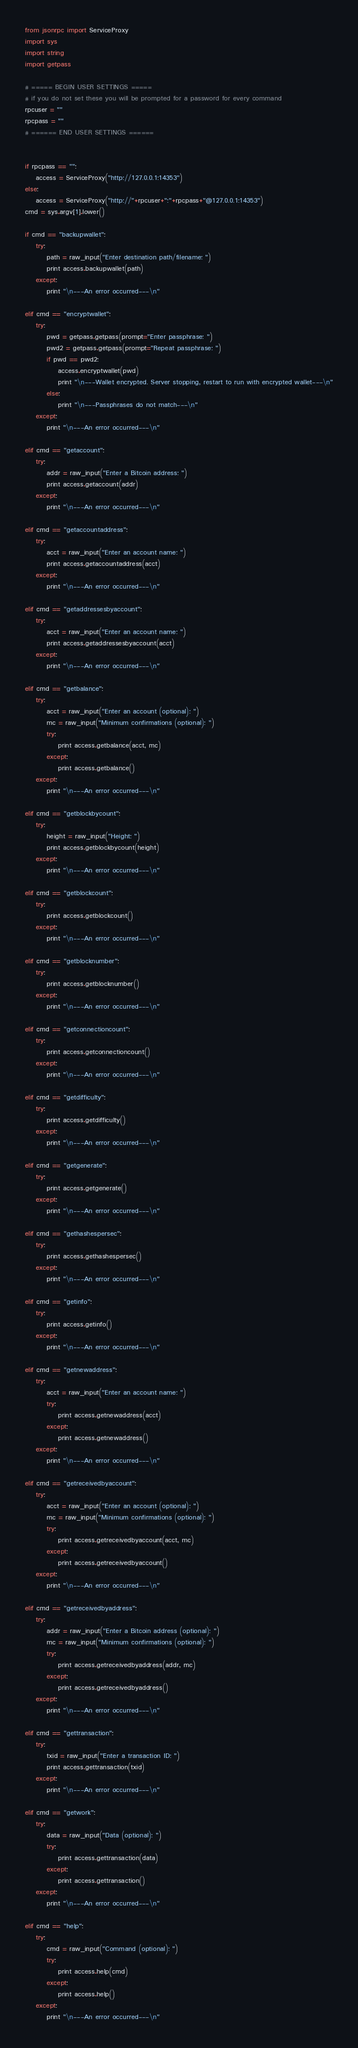<code> <loc_0><loc_0><loc_500><loc_500><_Python_>from jsonrpc import ServiceProxy
import sys
import string
import getpass

# ===== BEGIN USER SETTINGS =====
# if you do not set these you will be prompted for a password for every command
rpcuser = ""
rpcpass = ""
# ====== END USER SETTINGS ======


if rpcpass == "":
    access = ServiceProxy("http://127.0.0.1:14353")
else:
    access = ServiceProxy("http://"+rpcuser+":"+rpcpass+"@127.0.0.1:14353")
cmd = sys.argv[1].lower()

if cmd == "backupwallet":
    try:
        path = raw_input("Enter destination path/filename: ")
        print access.backupwallet(path)
    except:
        print "\n---An error occurred---\n"
        
elif cmd == "encryptwallet":
    try:
        pwd = getpass.getpass(prompt="Enter passphrase: ")
        pwd2 = getpass.getpass(prompt="Repeat passphrase: ")
        if pwd == pwd2:
            access.encryptwallet(pwd)
            print "\n---Wallet encrypted. Server stopping, restart to run with encrypted wallet---\n"
        else:
            print "\n---Passphrases do not match---\n"
    except:
        print "\n---An error occurred---\n"

elif cmd == "getaccount":
    try:
        addr = raw_input("Enter a Bitcoin address: ")
        print access.getaccount(addr)
    except:
        print "\n---An error occurred---\n"

elif cmd == "getaccountaddress":
    try:
        acct = raw_input("Enter an account name: ")
        print access.getaccountaddress(acct)
    except:
        print "\n---An error occurred---\n"

elif cmd == "getaddressesbyaccount":
    try:
        acct = raw_input("Enter an account name: ")
        print access.getaddressesbyaccount(acct)
    except:
        print "\n---An error occurred---\n"

elif cmd == "getbalance":
    try:
        acct = raw_input("Enter an account (optional): ")
        mc = raw_input("Minimum confirmations (optional): ")
        try:
            print access.getbalance(acct, mc)
        except:
            print access.getbalance()
    except:
        print "\n---An error occurred---\n"

elif cmd == "getblockbycount":
    try:
        height = raw_input("Height: ")
        print access.getblockbycount(height)
    except:
        print "\n---An error occurred---\n"

elif cmd == "getblockcount":
    try:
        print access.getblockcount()
    except:
        print "\n---An error occurred---\n"

elif cmd == "getblocknumber":
    try:
        print access.getblocknumber()
    except:
        print "\n---An error occurred---\n"

elif cmd == "getconnectioncount":
    try:
        print access.getconnectioncount()
    except:
        print "\n---An error occurred---\n"

elif cmd == "getdifficulty":
    try:
        print access.getdifficulty()
    except:
        print "\n---An error occurred---\n"

elif cmd == "getgenerate":
    try:
        print access.getgenerate()
    except:
        print "\n---An error occurred---\n"

elif cmd == "gethashespersec":
    try:
        print access.gethashespersec()
    except:
        print "\n---An error occurred---\n"

elif cmd == "getinfo":
    try:
        print access.getinfo()
    except:
        print "\n---An error occurred---\n"

elif cmd == "getnewaddress":
    try:
        acct = raw_input("Enter an account name: ")
        try:
            print access.getnewaddress(acct)
        except:
            print access.getnewaddress()
    except:
        print "\n---An error occurred---\n"

elif cmd == "getreceivedbyaccount":
    try:
        acct = raw_input("Enter an account (optional): ")
        mc = raw_input("Minimum confirmations (optional): ")
        try:
            print access.getreceivedbyaccount(acct, mc)
        except:
            print access.getreceivedbyaccount()
    except:
        print "\n---An error occurred---\n"

elif cmd == "getreceivedbyaddress":
    try:
        addr = raw_input("Enter a Bitcoin address (optional): ")
        mc = raw_input("Minimum confirmations (optional): ")
        try:
            print access.getreceivedbyaddress(addr, mc)
        except:
            print access.getreceivedbyaddress()
    except:
        print "\n---An error occurred---\n"

elif cmd == "gettransaction":
    try:
        txid = raw_input("Enter a transaction ID: ")
        print access.gettransaction(txid)
    except:
        print "\n---An error occurred---\n"

elif cmd == "getwork":
    try:
        data = raw_input("Data (optional): ")
        try:
            print access.gettransaction(data)
        except:
            print access.gettransaction()
    except:
        print "\n---An error occurred---\n"

elif cmd == "help":
    try:
        cmd = raw_input("Command (optional): ")
        try:
            print access.help(cmd)
        except:
            print access.help()
    except:
        print "\n---An error occurred---\n"
</code> 